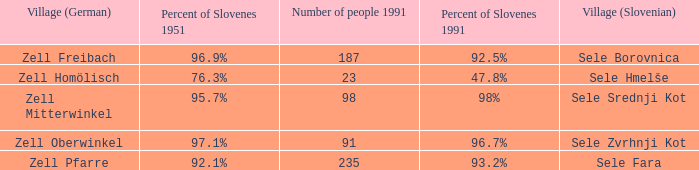Provide me with the name of the village (German) where there is 96.9% Slovenes in 1951.  Zell Freibach. 